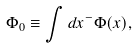<formula> <loc_0><loc_0><loc_500><loc_500>\Phi _ { 0 } \equiv \int d x ^ { - } \Phi ( x ) ,</formula> 